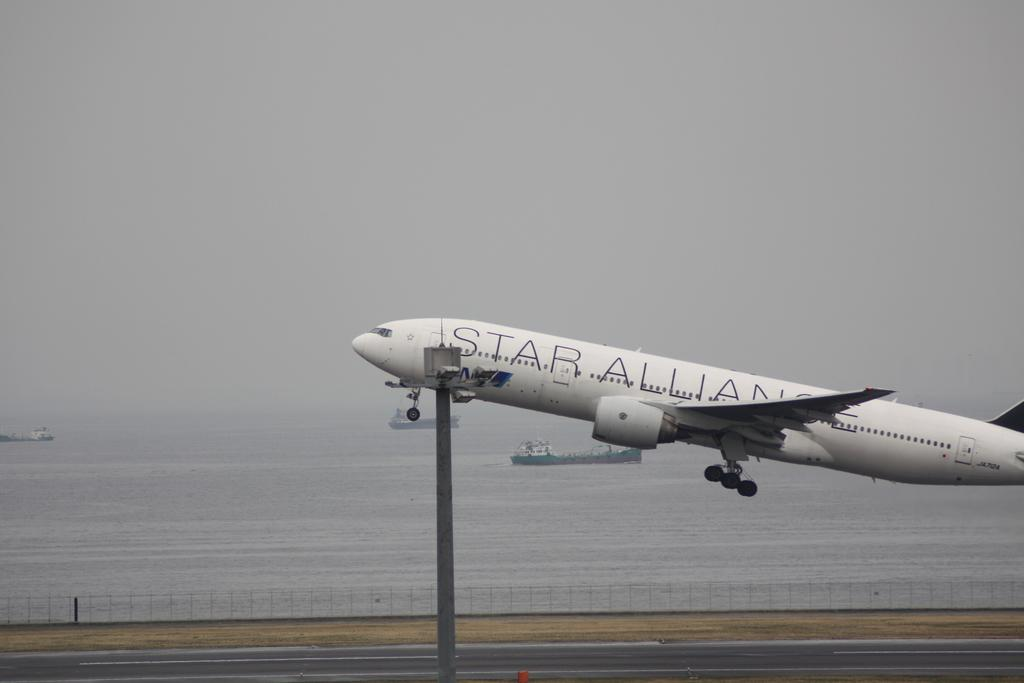<image>
Present a compact description of the photo's key features. A star alliance plane starting to ascend from the ground. 